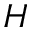<formula> <loc_0><loc_0><loc_500><loc_500>H</formula> 